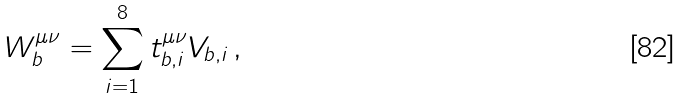<formula> <loc_0><loc_0><loc_500><loc_500>W _ { b } ^ { \mu \nu } = \sum _ { i = 1 } ^ { 8 } t _ { b , i } ^ { \mu \nu } V _ { b , i } \, ,</formula> 